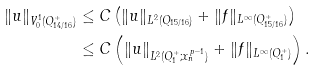Convert formula to latex. <formula><loc_0><loc_0><loc_500><loc_500>\| u \| _ { V _ { 0 } ^ { 1 } ( Q _ { 1 4 / 1 6 } ^ { + } ) } & \leq C \left ( \| u \| _ { L ^ { 2 } ( Q _ { 1 5 / 1 6 } ) } + \| f \| _ { L ^ { \infty } ( Q _ { 1 5 / 1 6 } ^ { + } ) } \right ) \\ & \leq C \left ( \| u \| _ { L ^ { 2 } ( Q _ { 1 } ^ { + } ; x _ { n } ^ { p - 1 } ) } + \| f \| _ { L ^ { \infty } ( Q _ { 1 } ^ { + } ) } \right ) .</formula> 